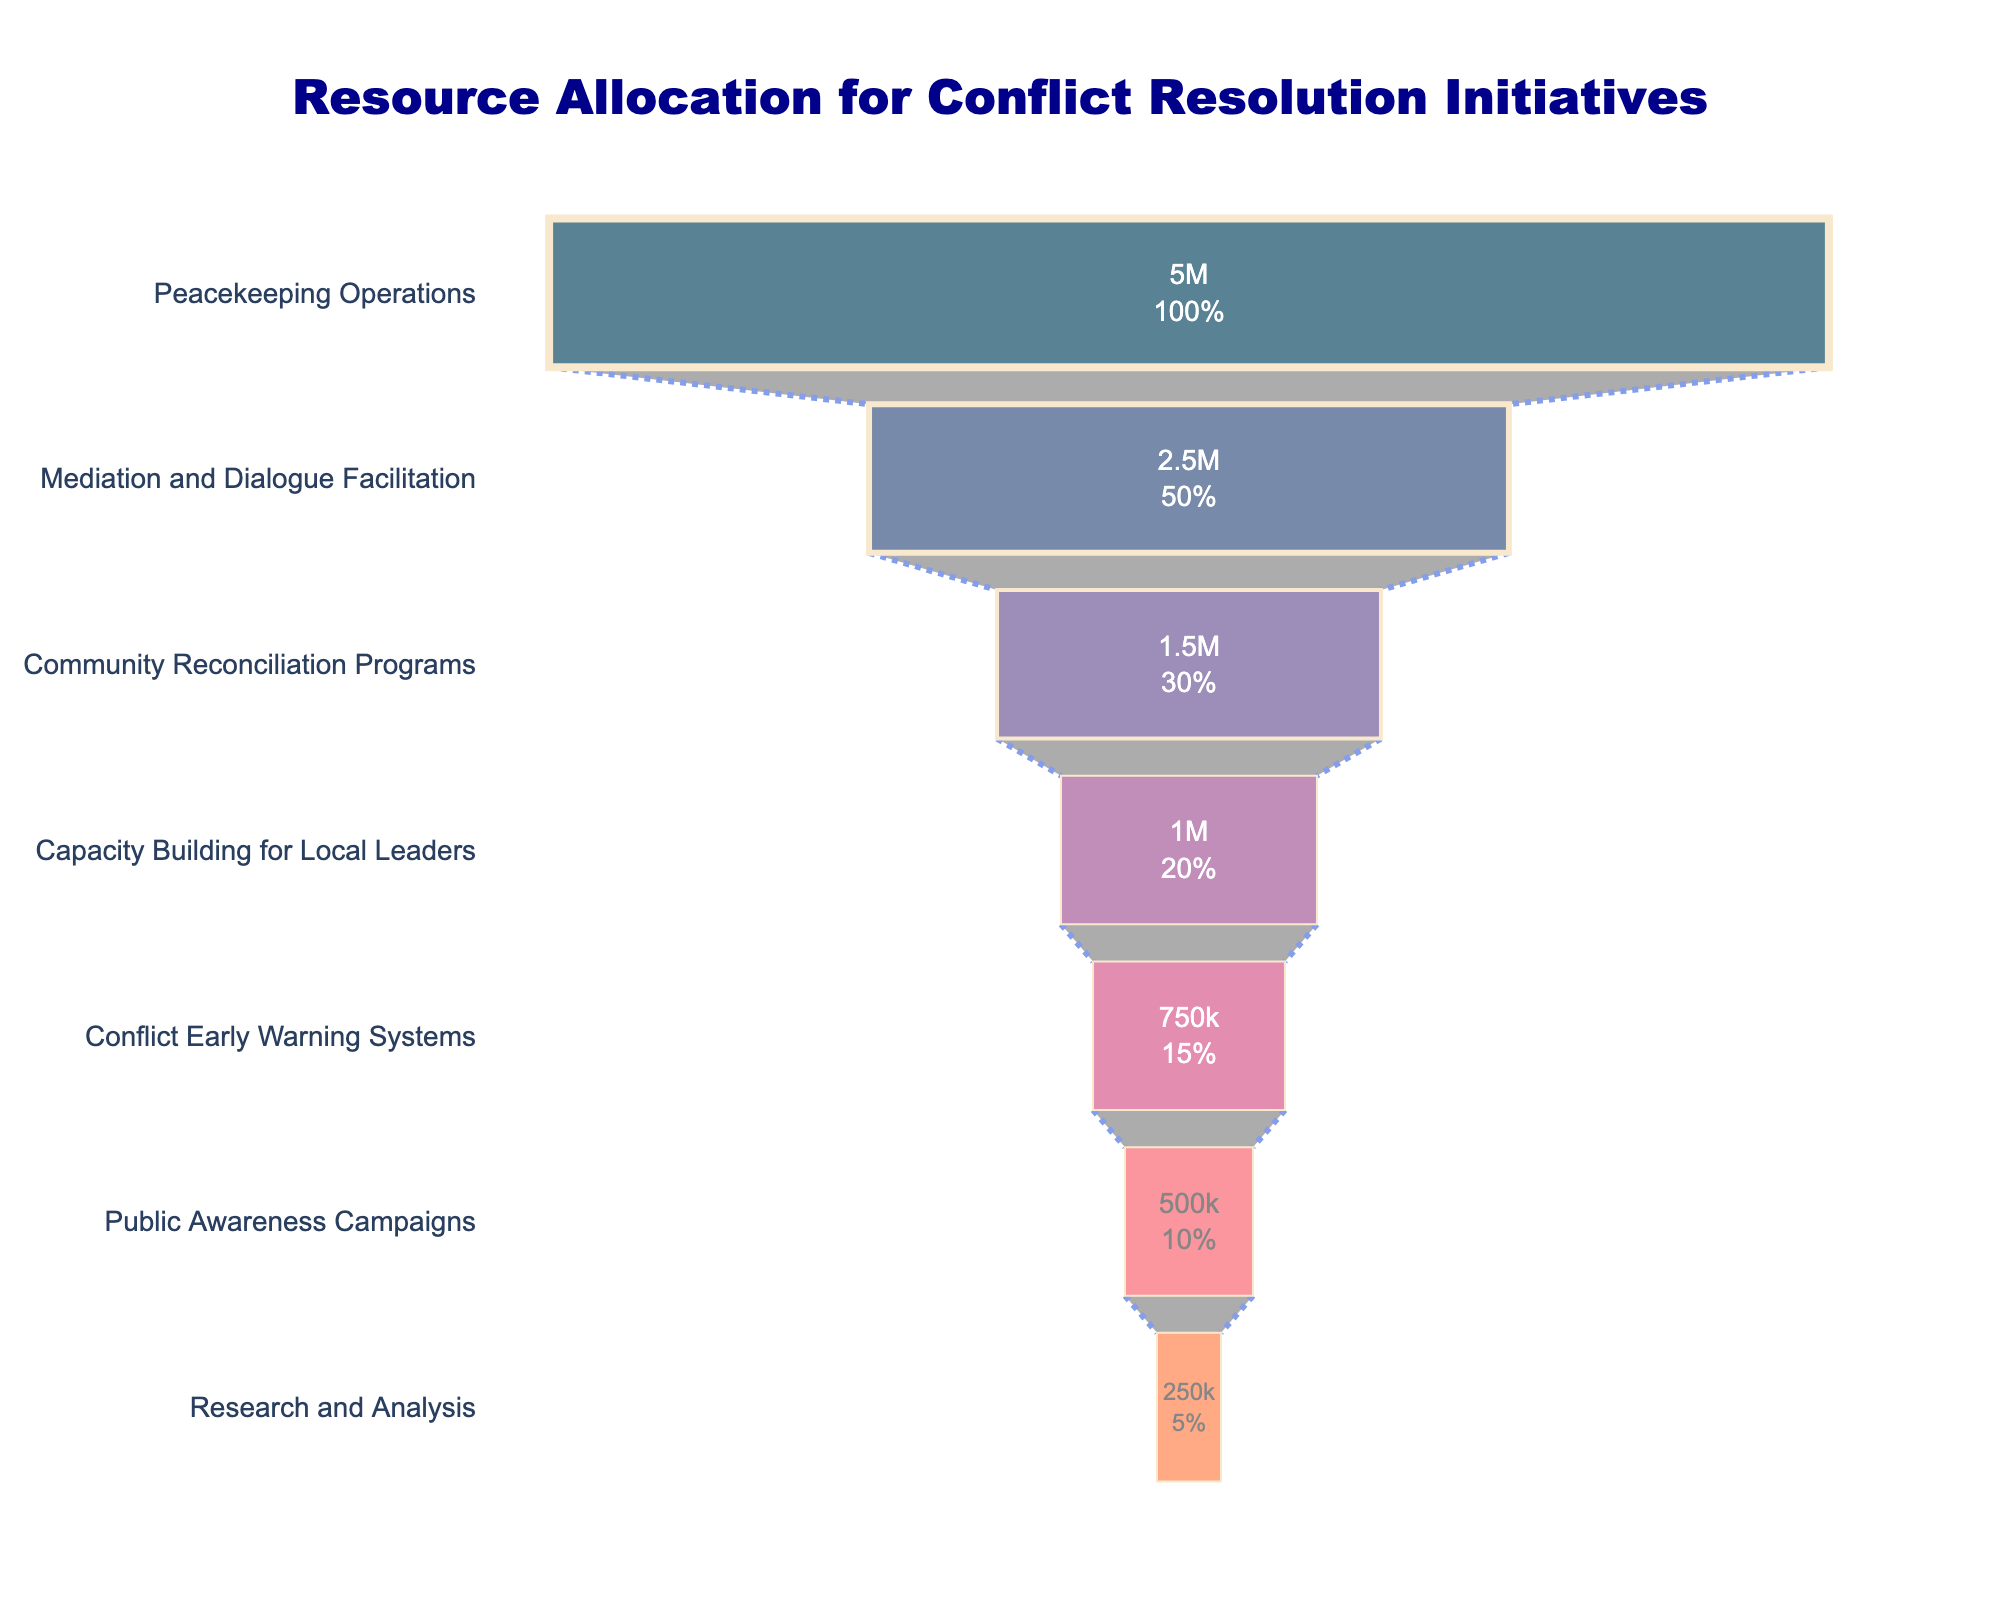What is the title of the funnel chart? The title of the funnel chart is displayed at the top of the figure, reading "Resource Allocation for Conflict Resolution Initiatives".
Answer: Resource Allocation for Conflict Resolution Initiatives Which stage has the highest budget allocation? By looking at the widest section (top) of the funnel chart, labeled with the highest value, "Peacekeeping Operations" has the highest budget allocation of $5,000,000.
Answer: Peacekeeping Operations What percentage of the total initial budget is allocated to Mediation and Dialogue Facilitation? The funnel chart typically gives percentages for each stage. Mediation and Dialogue Facilitation is the second stage, and the respective percentage is displayed within its section.
Answer: 25% How much more budget is allocated to Peacekeeping Operations compared to Conflict Early Warning Systems? The budget allocations are given directly on the chart: Peacekeeping Operations ($5,000,000) and Conflict Early Warning Systems ($750,000). Subtract the smaller budget from the larger one.
Answer: $4,250,000 What is the total budget for all initiatives combined? By summing the budgets for all stages: $5,000,000 + $2,500,000 + $1,500,000 + $1,000,000 + $750,000 + $500,000 + $250,000, the total budget is $11,500,000.
Answer: $11,500,000 Which initiative has a smaller budget: Public Awareness Campaigns or Research and Analysis? By comparing the budget allocations directly: Public Awareness Campaigns ($500,000) and Research and Analysis ($250,000), Research and Analysis has the smaller budget.
Answer: Research and Analysis How many initiative stages are below Community Reconciliation Programs in terms of budget allocation? Count the number of stages visible below "Community Reconciliation Programs" in the funnel chart: Capacity Building for Local Leaders, Conflict Early Warning Systems, Public Awareness Campaigns, and Research and Analysis.
Answer: 4 What is the difference in budget allocation between the Mediation and Dialogue Facilitation stage and the Capacity Building for Local Leaders stage? Subtract the budget of Capacity Building for Local Leaders from Mediation and Dialogue Facilitation: $2,500,000 - $1,000,000.
Answer: $1,500,000 What fraction of the total budget is allocated to Community Reconciliation Programs? Community Reconciliation Programs has a budget of $1,500,000. The total budget is $11,500,000. The fraction is $1,500,000/$11,500,000, which simplifies to approximately 3/23.
Answer: 3/23 